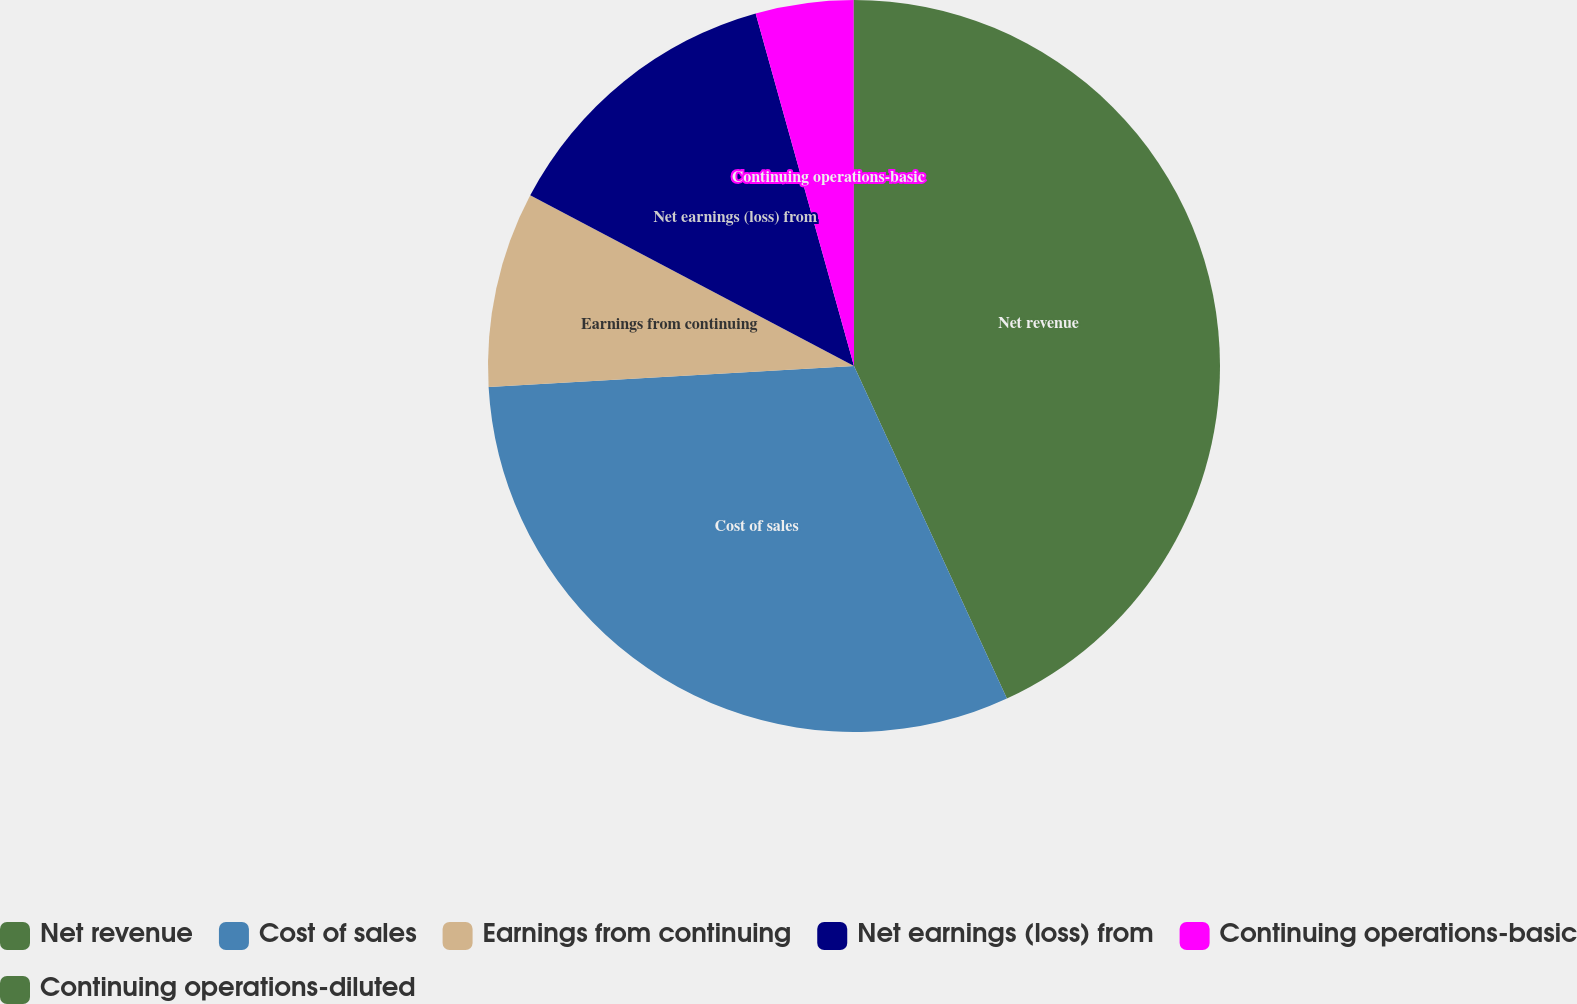Convert chart. <chart><loc_0><loc_0><loc_500><loc_500><pie_chart><fcel>Net revenue<fcel>Cost of sales<fcel>Earnings from continuing<fcel>Net earnings (loss) from<fcel>Continuing operations-basic<fcel>Continuing operations-diluted<nl><fcel>43.14%<fcel>30.95%<fcel>8.63%<fcel>12.95%<fcel>4.32%<fcel>0.01%<nl></chart> 